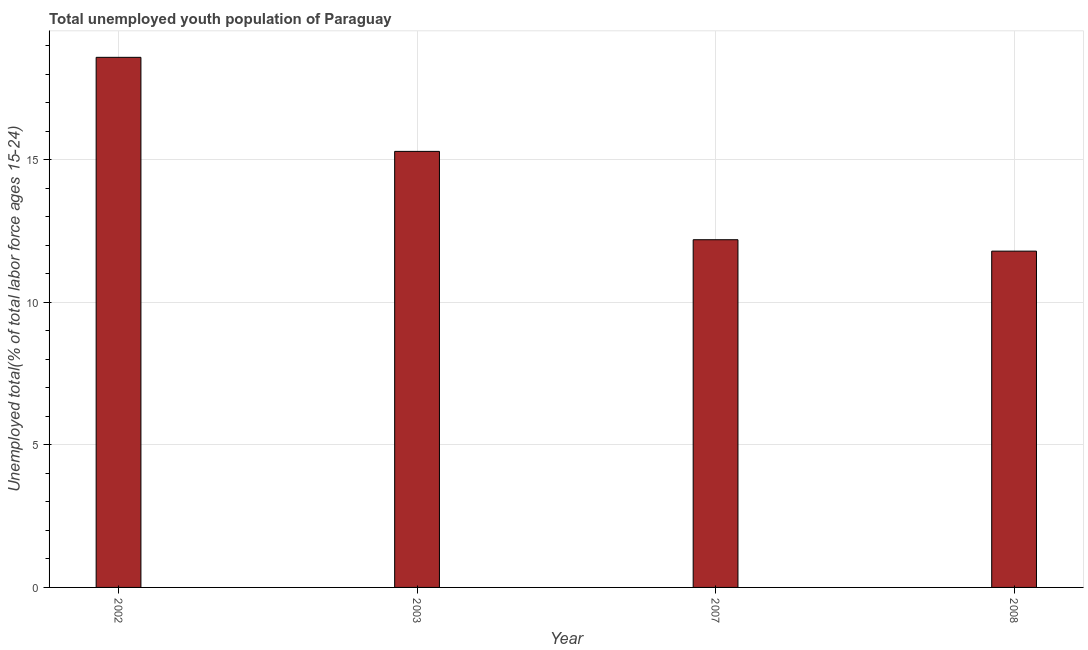Does the graph contain grids?
Keep it short and to the point. Yes. What is the title of the graph?
Make the answer very short. Total unemployed youth population of Paraguay. What is the label or title of the Y-axis?
Give a very brief answer. Unemployed total(% of total labor force ages 15-24). What is the unemployed youth in 2007?
Give a very brief answer. 12.2. Across all years, what is the maximum unemployed youth?
Your answer should be compact. 18.6. Across all years, what is the minimum unemployed youth?
Offer a very short reply. 11.8. In which year was the unemployed youth maximum?
Keep it short and to the point. 2002. What is the sum of the unemployed youth?
Your answer should be very brief. 57.9. What is the difference between the unemployed youth in 2002 and 2003?
Keep it short and to the point. 3.3. What is the average unemployed youth per year?
Make the answer very short. 14.47. What is the median unemployed youth?
Your answer should be very brief. 13.75. Do a majority of the years between 2008 and 2007 (inclusive) have unemployed youth greater than 15 %?
Your answer should be compact. No. What is the ratio of the unemployed youth in 2007 to that in 2008?
Offer a very short reply. 1.03. Is the unemployed youth in 2002 less than that in 2003?
Give a very brief answer. No. What is the difference between the highest and the second highest unemployed youth?
Offer a very short reply. 3.3. Is the sum of the unemployed youth in 2003 and 2008 greater than the maximum unemployed youth across all years?
Offer a terse response. Yes. In how many years, is the unemployed youth greater than the average unemployed youth taken over all years?
Give a very brief answer. 2. Are all the bars in the graph horizontal?
Your response must be concise. No. What is the difference between two consecutive major ticks on the Y-axis?
Your answer should be compact. 5. What is the Unemployed total(% of total labor force ages 15-24) of 2002?
Ensure brevity in your answer.  18.6. What is the Unemployed total(% of total labor force ages 15-24) in 2003?
Keep it short and to the point. 15.3. What is the Unemployed total(% of total labor force ages 15-24) of 2007?
Provide a short and direct response. 12.2. What is the Unemployed total(% of total labor force ages 15-24) in 2008?
Ensure brevity in your answer.  11.8. What is the difference between the Unemployed total(% of total labor force ages 15-24) in 2002 and 2003?
Give a very brief answer. 3.3. What is the difference between the Unemployed total(% of total labor force ages 15-24) in 2002 and 2007?
Offer a very short reply. 6.4. What is the difference between the Unemployed total(% of total labor force ages 15-24) in 2003 and 2007?
Provide a succinct answer. 3.1. What is the difference between the Unemployed total(% of total labor force ages 15-24) in 2003 and 2008?
Provide a succinct answer. 3.5. What is the ratio of the Unemployed total(% of total labor force ages 15-24) in 2002 to that in 2003?
Give a very brief answer. 1.22. What is the ratio of the Unemployed total(% of total labor force ages 15-24) in 2002 to that in 2007?
Provide a short and direct response. 1.52. What is the ratio of the Unemployed total(% of total labor force ages 15-24) in 2002 to that in 2008?
Your response must be concise. 1.58. What is the ratio of the Unemployed total(% of total labor force ages 15-24) in 2003 to that in 2007?
Ensure brevity in your answer.  1.25. What is the ratio of the Unemployed total(% of total labor force ages 15-24) in 2003 to that in 2008?
Make the answer very short. 1.3. What is the ratio of the Unemployed total(% of total labor force ages 15-24) in 2007 to that in 2008?
Provide a short and direct response. 1.03. 